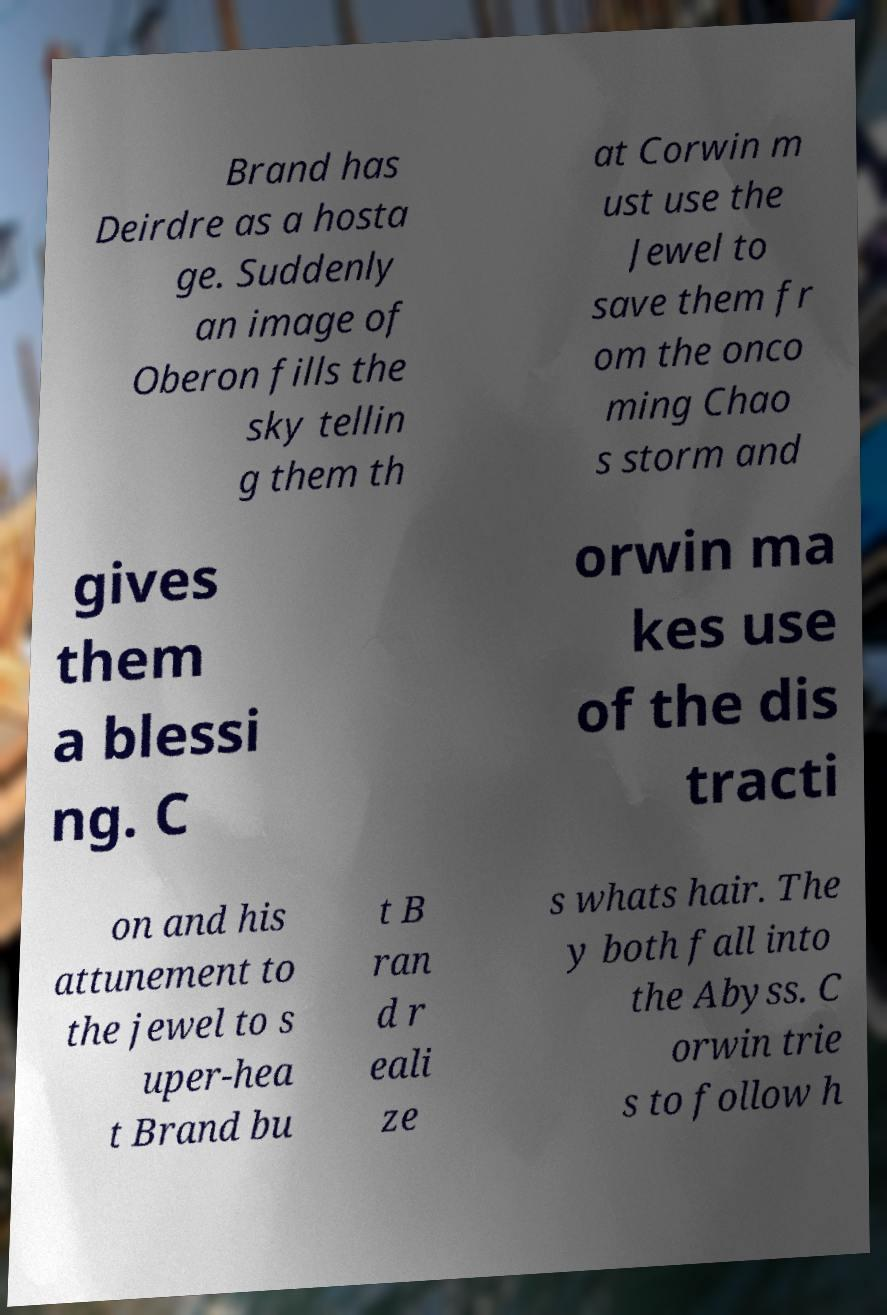Could you extract and type out the text from this image? Brand has Deirdre as a hosta ge. Suddenly an image of Oberon fills the sky tellin g them th at Corwin m ust use the Jewel to save them fr om the onco ming Chao s storm and gives them a blessi ng. C orwin ma kes use of the dis tracti on and his attunement to the jewel to s uper-hea t Brand bu t B ran d r eali ze s whats hair. The y both fall into the Abyss. C orwin trie s to follow h 